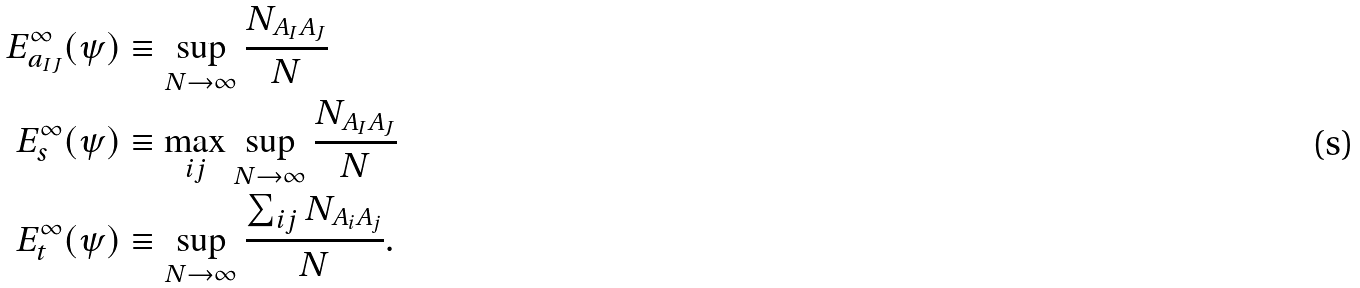<formula> <loc_0><loc_0><loc_500><loc_500>E ^ { \infty } _ { a _ { I J } } ( \psi ) & \equiv \sup _ { N \to \infty } \frac { N _ { A _ { I } A _ { J } } } { N } \\ E ^ { \infty } _ { s } ( \psi ) & \equiv \max _ { i j } \sup _ { N \to \infty } \frac { N _ { A _ { I } A _ { J } } } { N } \\ E ^ { \infty } _ { t } ( \psi ) & \equiv \sup _ { N \to \infty } \frac { \sum _ { i j } N _ { A _ { i } A _ { j } } } { N } .</formula> 